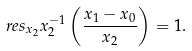Convert formula to latex. <formula><loc_0><loc_0><loc_500><loc_500>\ r e s _ { x _ { 2 } } x _ { 2 } ^ { - 1 } \left ( \frac { x _ { 1 } - x _ { 0 } } { x _ { 2 } } \right ) = 1 .</formula> 